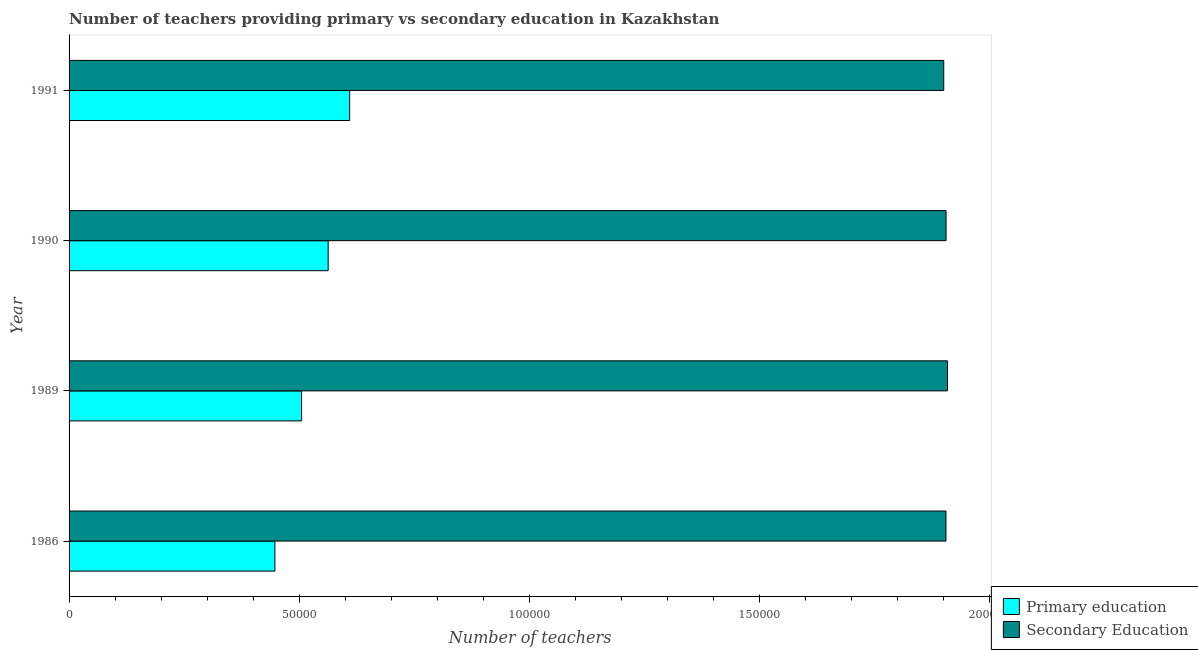How many groups of bars are there?
Give a very brief answer. 4. How many bars are there on the 3rd tick from the bottom?
Provide a short and direct response. 2. What is the label of the 2nd group of bars from the top?
Offer a very short reply. 1990. What is the number of primary teachers in 1991?
Your response must be concise. 6.09e+04. Across all years, what is the maximum number of primary teachers?
Make the answer very short. 6.09e+04. Across all years, what is the minimum number of secondary teachers?
Provide a short and direct response. 1.90e+05. What is the total number of secondary teachers in the graph?
Offer a terse response. 7.62e+05. What is the difference between the number of primary teachers in 1986 and that in 1989?
Give a very brief answer. -5800. What is the difference between the number of primary teachers in 1986 and the number of secondary teachers in 1990?
Offer a very short reply. -1.46e+05. What is the average number of secondary teachers per year?
Your response must be concise. 1.90e+05. In the year 1991, what is the difference between the number of secondary teachers and number of primary teachers?
Your answer should be compact. 1.29e+05. What is the difference between the highest and the second highest number of secondary teachers?
Offer a very short reply. 301. What is the difference between the highest and the lowest number of secondary teachers?
Offer a very short reply. 805. What does the 1st bar from the top in 1991 represents?
Your answer should be compact. Secondary Education. What does the 2nd bar from the bottom in 1989 represents?
Provide a short and direct response. Secondary Education. How many bars are there?
Your response must be concise. 8. Does the graph contain grids?
Ensure brevity in your answer.  No. Where does the legend appear in the graph?
Provide a short and direct response. Bottom right. What is the title of the graph?
Your response must be concise. Number of teachers providing primary vs secondary education in Kazakhstan. What is the label or title of the X-axis?
Your response must be concise. Number of teachers. What is the Number of teachers in Primary education in 1986?
Provide a succinct answer. 4.47e+04. What is the Number of teachers of Secondary Education in 1986?
Ensure brevity in your answer.  1.90e+05. What is the Number of teachers in Primary education in 1989?
Ensure brevity in your answer.  5.05e+04. What is the Number of teachers in Secondary Education in 1989?
Your answer should be very brief. 1.91e+05. What is the Number of teachers in Primary education in 1990?
Provide a short and direct response. 5.63e+04. What is the Number of teachers of Secondary Education in 1990?
Provide a short and direct response. 1.90e+05. What is the Number of teachers of Primary education in 1991?
Your answer should be very brief. 6.09e+04. What is the Number of teachers in Secondary Education in 1991?
Provide a succinct answer. 1.90e+05. Across all years, what is the maximum Number of teachers of Primary education?
Offer a very short reply. 6.09e+04. Across all years, what is the maximum Number of teachers in Secondary Education?
Keep it short and to the point. 1.91e+05. Across all years, what is the minimum Number of teachers in Primary education?
Your response must be concise. 4.47e+04. Across all years, what is the minimum Number of teachers in Secondary Education?
Make the answer very short. 1.90e+05. What is the total Number of teachers in Primary education in the graph?
Your answer should be very brief. 2.12e+05. What is the total Number of teachers of Secondary Education in the graph?
Your response must be concise. 7.62e+05. What is the difference between the Number of teachers in Primary education in 1986 and that in 1989?
Ensure brevity in your answer.  -5800. What is the difference between the Number of teachers in Secondary Education in 1986 and that in 1989?
Your response must be concise. -324. What is the difference between the Number of teachers in Primary education in 1986 and that in 1990?
Ensure brevity in your answer.  -1.16e+04. What is the difference between the Number of teachers of Secondary Education in 1986 and that in 1990?
Your response must be concise. -23. What is the difference between the Number of teachers of Primary education in 1986 and that in 1991?
Offer a terse response. -1.62e+04. What is the difference between the Number of teachers in Secondary Education in 1986 and that in 1991?
Provide a succinct answer. 481. What is the difference between the Number of teachers in Primary education in 1989 and that in 1990?
Give a very brief answer. -5774. What is the difference between the Number of teachers in Secondary Education in 1989 and that in 1990?
Offer a very short reply. 301. What is the difference between the Number of teachers of Primary education in 1989 and that in 1991?
Make the answer very short. -1.04e+04. What is the difference between the Number of teachers in Secondary Education in 1989 and that in 1991?
Offer a terse response. 805. What is the difference between the Number of teachers of Primary education in 1990 and that in 1991?
Provide a short and direct response. -4668. What is the difference between the Number of teachers in Secondary Education in 1990 and that in 1991?
Your response must be concise. 504. What is the difference between the Number of teachers in Primary education in 1986 and the Number of teachers in Secondary Education in 1989?
Keep it short and to the point. -1.46e+05. What is the difference between the Number of teachers of Primary education in 1986 and the Number of teachers of Secondary Education in 1990?
Your response must be concise. -1.46e+05. What is the difference between the Number of teachers of Primary education in 1986 and the Number of teachers of Secondary Education in 1991?
Your response must be concise. -1.45e+05. What is the difference between the Number of teachers of Primary education in 1989 and the Number of teachers of Secondary Education in 1990?
Offer a terse response. -1.40e+05. What is the difference between the Number of teachers of Primary education in 1989 and the Number of teachers of Secondary Education in 1991?
Your response must be concise. -1.39e+05. What is the difference between the Number of teachers of Primary education in 1990 and the Number of teachers of Secondary Education in 1991?
Offer a terse response. -1.34e+05. What is the average Number of teachers of Primary education per year?
Ensure brevity in your answer.  5.31e+04. What is the average Number of teachers in Secondary Education per year?
Provide a succinct answer. 1.90e+05. In the year 1986, what is the difference between the Number of teachers of Primary education and Number of teachers of Secondary Education?
Offer a very short reply. -1.46e+05. In the year 1989, what is the difference between the Number of teachers of Primary education and Number of teachers of Secondary Education?
Offer a terse response. -1.40e+05. In the year 1990, what is the difference between the Number of teachers of Primary education and Number of teachers of Secondary Education?
Make the answer very short. -1.34e+05. In the year 1991, what is the difference between the Number of teachers of Primary education and Number of teachers of Secondary Education?
Keep it short and to the point. -1.29e+05. What is the ratio of the Number of teachers in Primary education in 1986 to that in 1989?
Give a very brief answer. 0.89. What is the ratio of the Number of teachers of Primary education in 1986 to that in 1990?
Provide a succinct answer. 0.79. What is the ratio of the Number of teachers in Secondary Education in 1986 to that in 1990?
Ensure brevity in your answer.  1. What is the ratio of the Number of teachers in Primary education in 1986 to that in 1991?
Provide a short and direct response. 0.73. What is the ratio of the Number of teachers of Secondary Education in 1986 to that in 1991?
Your response must be concise. 1. What is the ratio of the Number of teachers in Primary education in 1989 to that in 1990?
Offer a terse response. 0.9. What is the ratio of the Number of teachers of Secondary Education in 1989 to that in 1990?
Your response must be concise. 1. What is the ratio of the Number of teachers in Primary education in 1989 to that in 1991?
Your answer should be compact. 0.83. What is the ratio of the Number of teachers in Primary education in 1990 to that in 1991?
Offer a very short reply. 0.92. What is the ratio of the Number of teachers of Secondary Education in 1990 to that in 1991?
Offer a very short reply. 1. What is the difference between the highest and the second highest Number of teachers in Primary education?
Offer a terse response. 4668. What is the difference between the highest and the second highest Number of teachers in Secondary Education?
Offer a terse response. 301. What is the difference between the highest and the lowest Number of teachers of Primary education?
Offer a very short reply. 1.62e+04. What is the difference between the highest and the lowest Number of teachers in Secondary Education?
Ensure brevity in your answer.  805. 